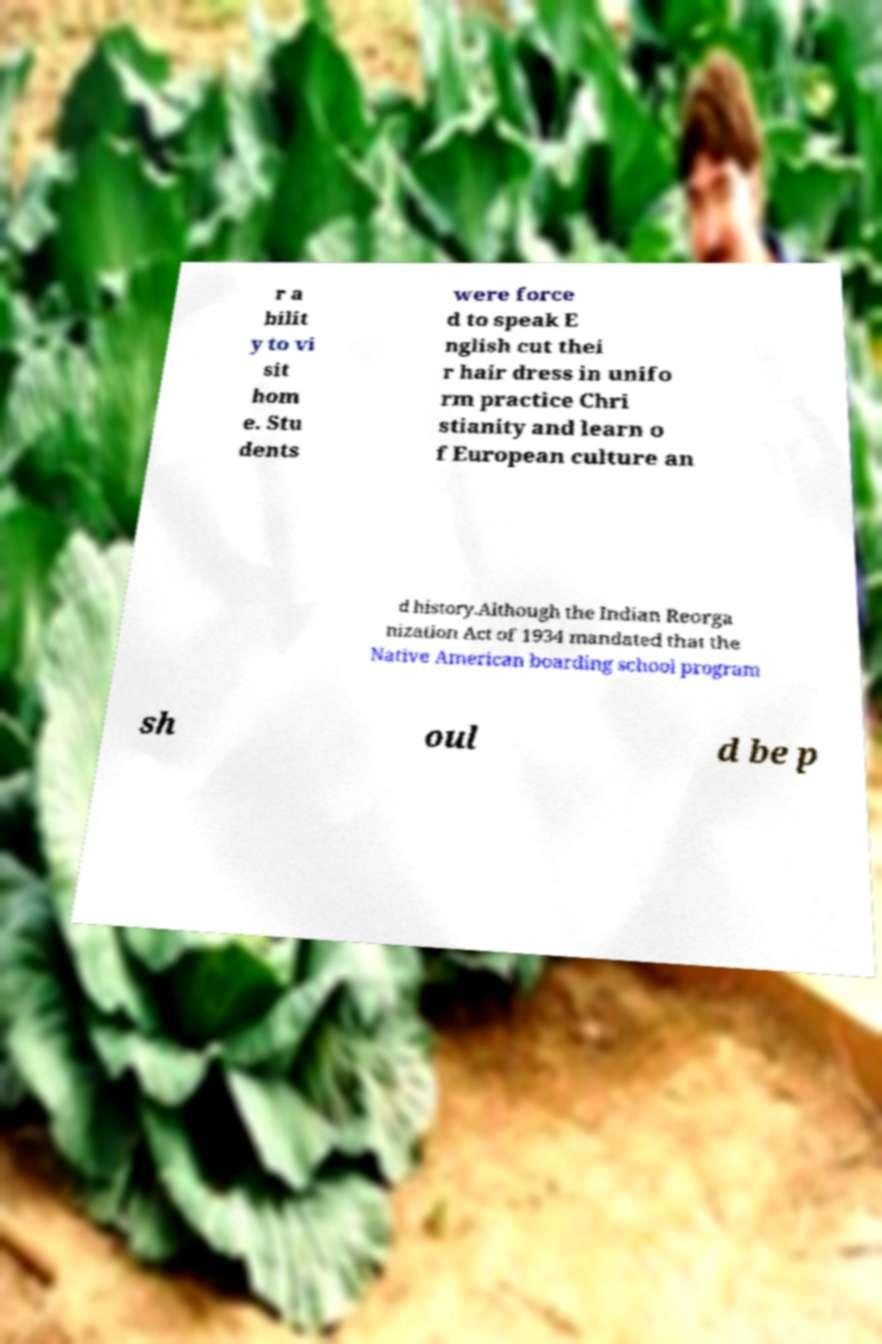Please identify and transcribe the text found in this image. r a bilit y to vi sit hom e. Stu dents were force d to speak E nglish cut thei r hair dress in unifo rm practice Chri stianity and learn o f European culture an d history.Although the Indian Reorga nization Act of 1934 mandated that the Native American boarding school program sh oul d be p 